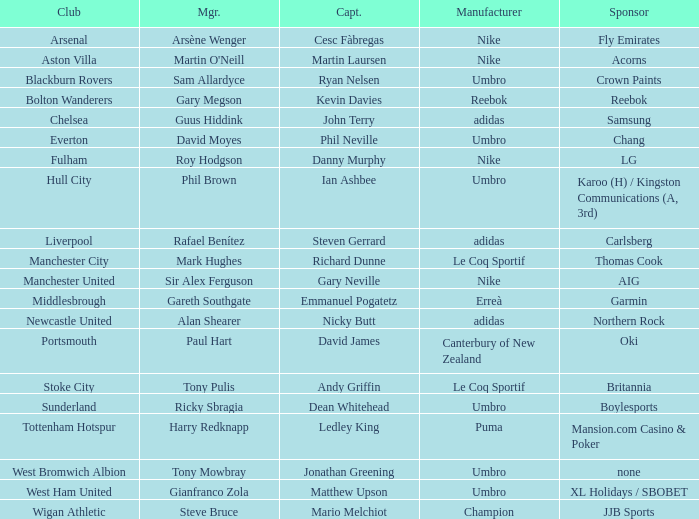Who is Dean Whitehead's manager? Ricky Sbragia. 